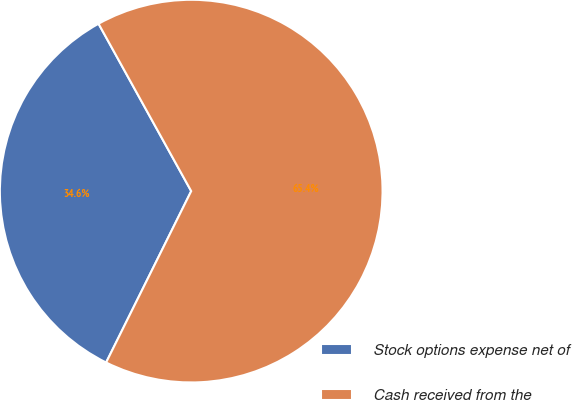Convert chart. <chart><loc_0><loc_0><loc_500><loc_500><pie_chart><fcel>Stock options expense net of<fcel>Cash received from the<nl><fcel>34.62%<fcel>65.38%<nl></chart> 